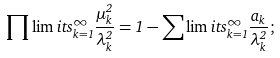<formula> <loc_0><loc_0><loc_500><loc_500>\prod \lim i t s _ { k = 1 } ^ { \infty } \frac { \mu _ { k } ^ { 2 } } { \lambda _ { k } ^ { 2 } } = 1 - \sum \lim i t s _ { k = 1 } ^ { \infty } \frac { a _ { k } } { \lambda _ { k } ^ { 2 } } ;</formula> 